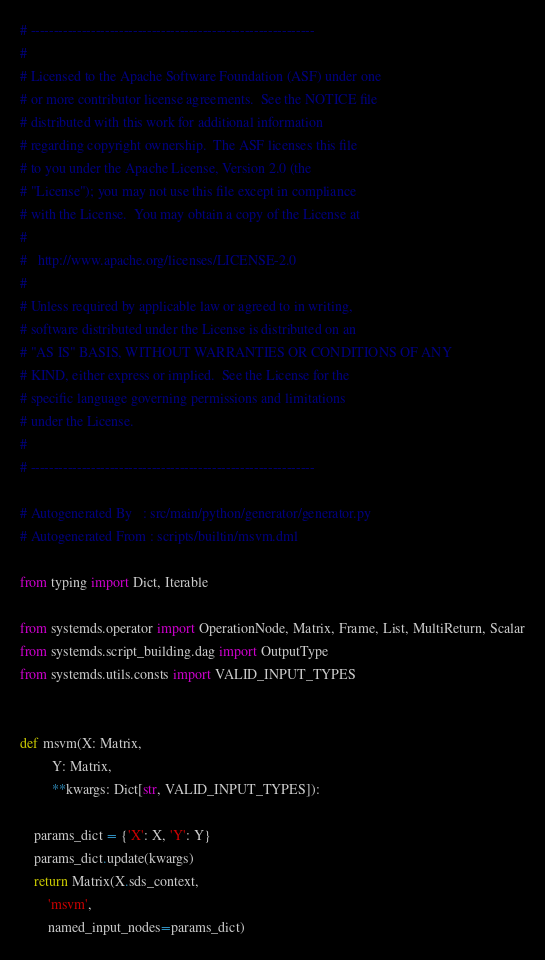Convert code to text. <code><loc_0><loc_0><loc_500><loc_500><_Python_># -------------------------------------------------------------
#
# Licensed to the Apache Software Foundation (ASF) under one
# or more contributor license agreements.  See the NOTICE file
# distributed with this work for additional information
# regarding copyright ownership.  The ASF licenses this file
# to you under the Apache License, Version 2.0 (the
# "License"); you may not use this file except in compliance
# with the License.  You may obtain a copy of the License at
#
#   http://www.apache.org/licenses/LICENSE-2.0
#
# Unless required by applicable law or agreed to in writing,
# software distributed under the License is distributed on an
# "AS IS" BASIS, WITHOUT WARRANTIES OR CONDITIONS OF ANY
# KIND, either express or implied.  See the License for the
# specific language governing permissions and limitations
# under the License.
#
# -------------------------------------------------------------

# Autogenerated By   : src/main/python/generator/generator.py
# Autogenerated From : scripts/builtin/msvm.dml

from typing import Dict, Iterable

from systemds.operator import OperationNode, Matrix, Frame, List, MultiReturn, Scalar
from systemds.script_building.dag import OutputType
from systemds.utils.consts import VALID_INPUT_TYPES


def msvm(X: Matrix,
         Y: Matrix,
         **kwargs: Dict[str, VALID_INPUT_TYPES]):
    
    params_dict = {'X': X, 'Y': Y}
    params_dict.update(kwargs)
    return Matrix(X.sds_context,
        'msvm',
        named_input_nodes=params_dict)
</code> 